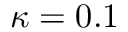Convert formula to latex. <formula><loc_0><loc_0><loc_500><loc_500>\kappa = 0 . 1</formula> 